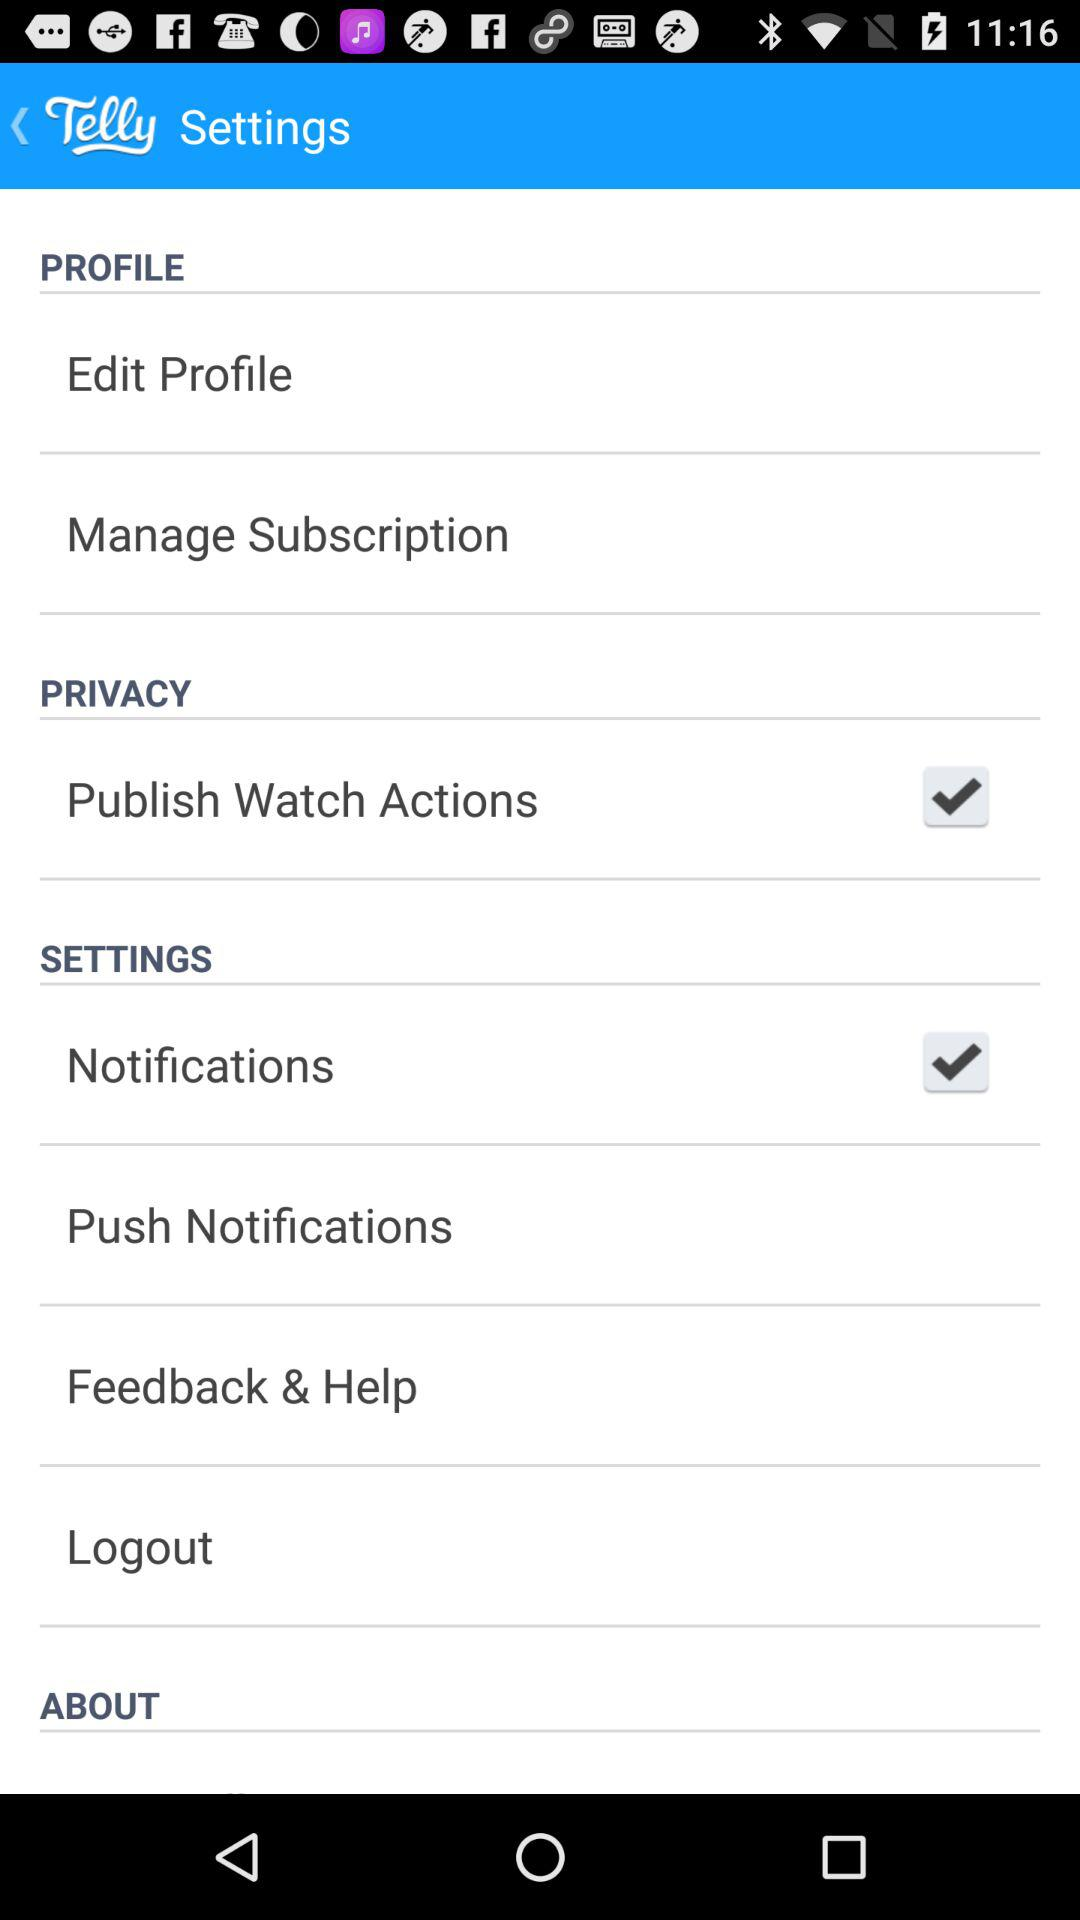What is the current state of "Publish Watch Actions"? The current state is on. 